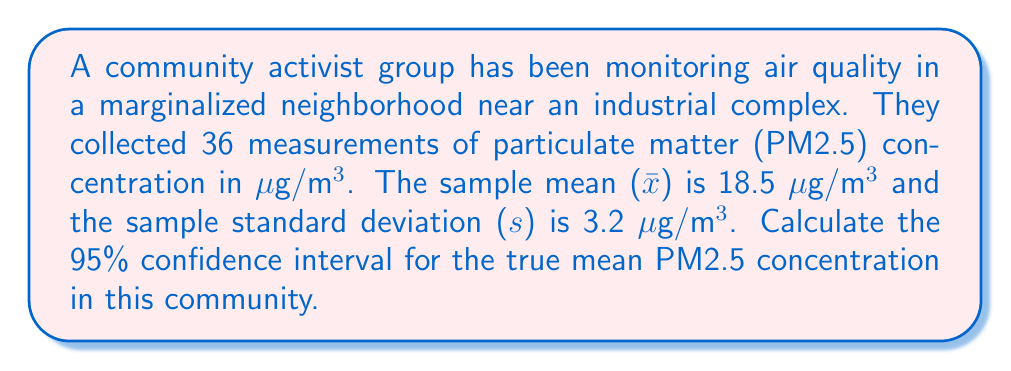Give your solution to this math problem. To calculate the confidence interval, we'll use the formula:

$$ \text{CI} = \bar{x} \pm t_{\alpha/2} \cdot \frac{s}{\sqrt{n}} $$

Where:
- $\bar{x}$ is the sample mean (18.5 μg/m³)
- $s$ is the sample standard deviation (3.2 μg/m³)
- $n$ is the sample size (36)
- $t_{\alpha/2}$ is the t-value for a 95% confidence level with n-1 degrees of freedom

Steps:
1) Find $t_{\alpha/2}$:
   - Degrees of freedom = n - 1 = 36 - 1 = 35
   - For a 95% CI, α = 0.05
   - Using a t-table or calculator, we find $t_{0.025,35} \approx 2.030$

2) Calculate the margin of error:
   $$ \text{ME} = t_{\alpha/2} \cdot \frac{s}{\sqrt{n}} = 2.030 \cdot \frac{3.2}{\sqrt{36}} \approx 1.08 $$

3) Calculate the confidence interval:
   $$ \text{CI} = 18.5 \pm 1.08 $$
   $$ \text{Lower bound} = 18.5 - 1.08 = 17.42 $$
   $$ \text{Upper bound} = 18.5 + 1.08 = 19.58 $$

Thus, we are 95% confident that the true mean PM2.5 concentration in this community is between 17.42 and 19.58 μg/m³.
Answer: (17.42, 19.58) μg/m³ 